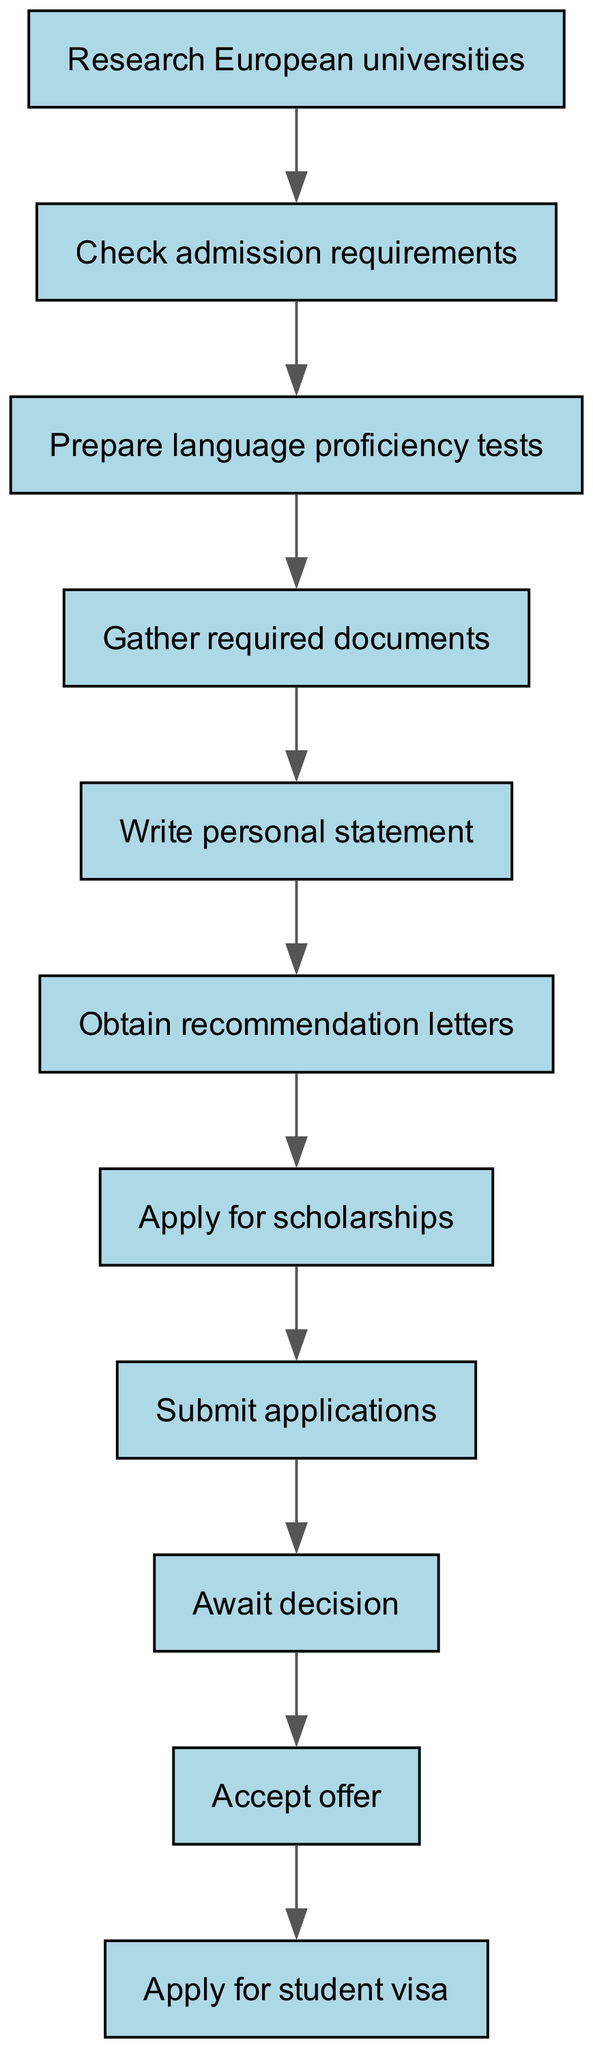What is the starting step in the application process? The diagram indicates that the first step is "Research European universities".
Answer: Research European universities How many nodes are there in the diagram? The diagram lists a total of 10 distinct nodes that represent steps in the application process.
Answer: 10 What is the last step before applying for a student visa? According to the flowchart, the step prior to applying for a student visa is "Accept offer".
Answer: Accept offer What is required after writing a personal statement? The diagram shows that the next step following the writing of a personal statement is to "Obtain recommendation letters".
Answer: Obtain recommendation letters What happens immediately after submitting applications? Following the submission of applications, the next action in the flowchart is "Await decision".
Answer: Await decision What step involves financial assistance? The flowchart includes "Apply for scholarships" as the step related to seeking financial assistance while applying to universities.
Answer: Apply for scholarships How many edges are there in the diagram? The diagram records 9 directed edges that connect the various nodes, representing the flow from one step to the next.
Answer: 9 Which step comes after gathering required documents? The diagram indicates that after gathering required documents, the next step is to "Write personal statement".
Answer: Write personal statement Which step directly follows preparing language proficiency tests? According to the diagram, the step that follows preparing for language proficiency tests is "Gather required documents".
Answer: Gather required documents 